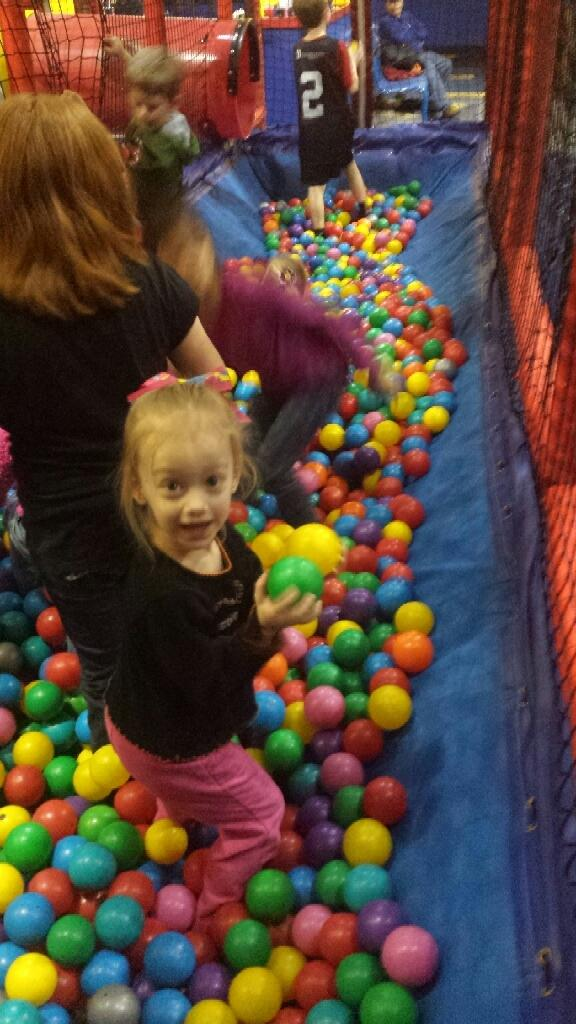What type of area is shown in the image? The image depicts a kids play zone. What are the kids playing with in the play zone? The kids are playing with color balls in the image. What is used to enclose the play area? There is a net surrounding the play area. Can you describe the person sitting near the play area? A person is sitting on a chair behind the net. What type of shoes are the kids wearing while playing with the pin in the image? There is no pin or shoes mentioned in the image; the kids are playing with color balls, and there is no reference to any footwear. 